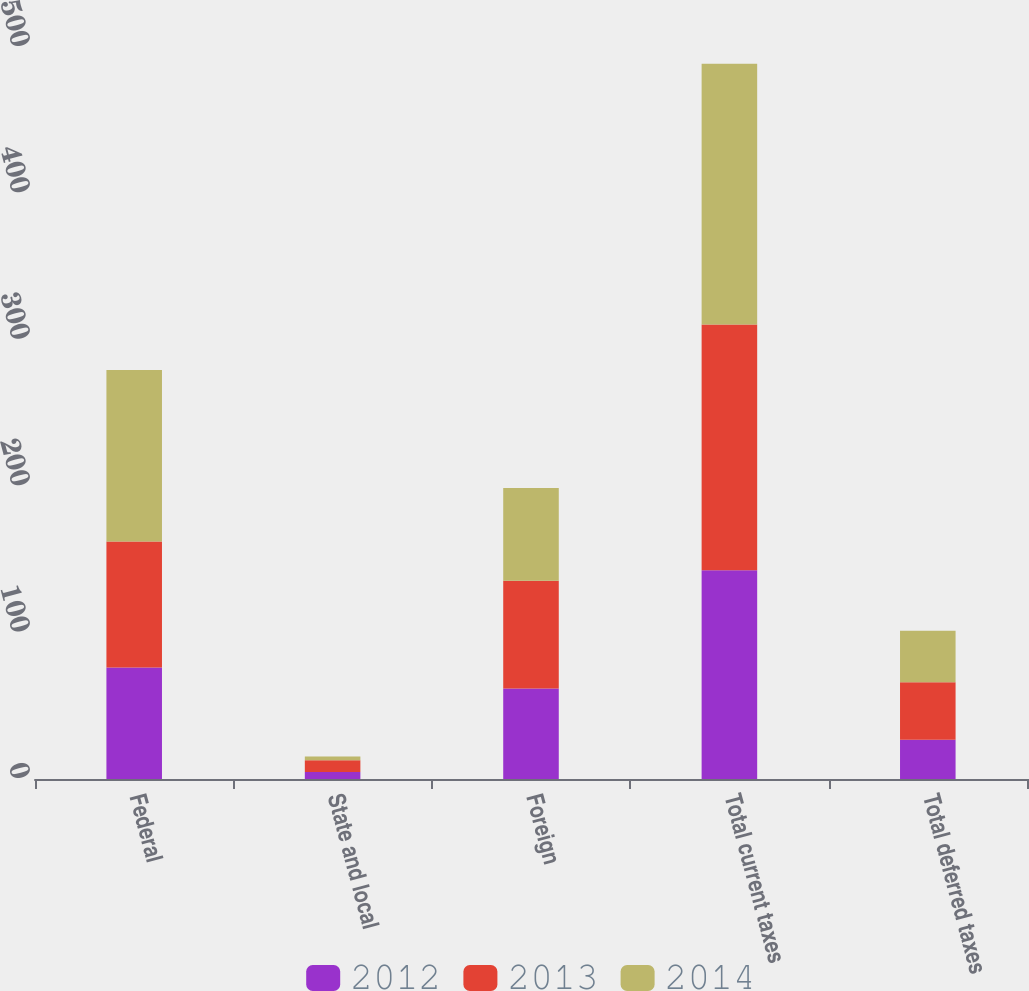<chart> <loc_0><loc_0><loc_500><loc_500><stacked_bar_chart><ecel><fcel>Federal<fcel>State and local<fcel>Foreign<fcel>Total current taxes<fcel>Total deferred taxes<nl><fcel>2012<fcel>76.1<fcel>4.7<fcel>61.8<fcel>142.6<fcel>26.8<nl><fcel>2013<fcel>86.1<fcel>8.1<fcel>73.6<fcel>167.8<fcel>39.3<nl><fcel>2014<fcel>117.2<fcel>2.5<fcel>63.4<fcel>178.1<fcel>35.2<nl></chart> 